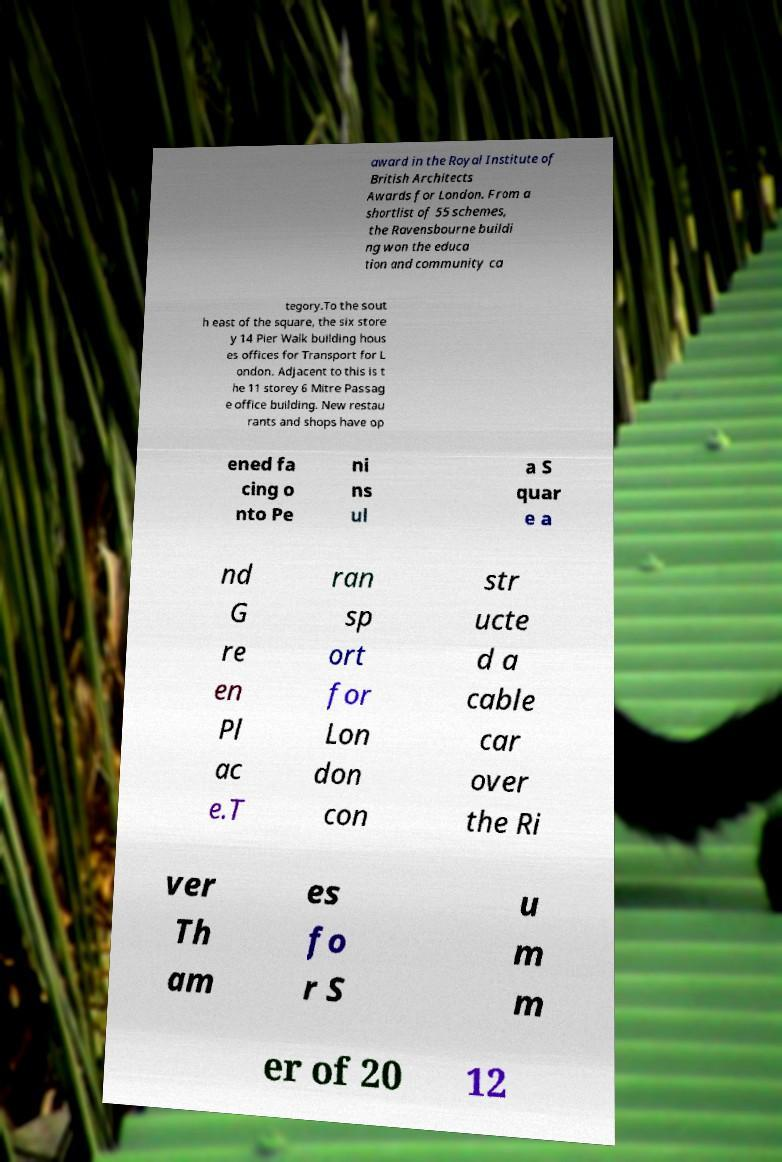Can you read and provide the text displayed in the image?This photo seems to have some interesting text. Can you extract and type it out for me? award in the Royal Institute of British Architects Awards for London. From a shortlist of 55 schemes, the Ravensbourne buildi ng won the educa tion and community ca tegory.To the sout h east of the square, the six store y 14 Pier Walk building hous es offices for Transport for L ondon. Adjacent to this is t he 11 storey 6 Mitre Passag e office building. New restau rants and shops have op ened fa cing o nto Pe ni ns ul a S quar e a nd G re en Pl ac e.T ran sp ort for Lon don con str ucte d a cable car over the Ri ver Th am es fo r S u m m er of 20 12 